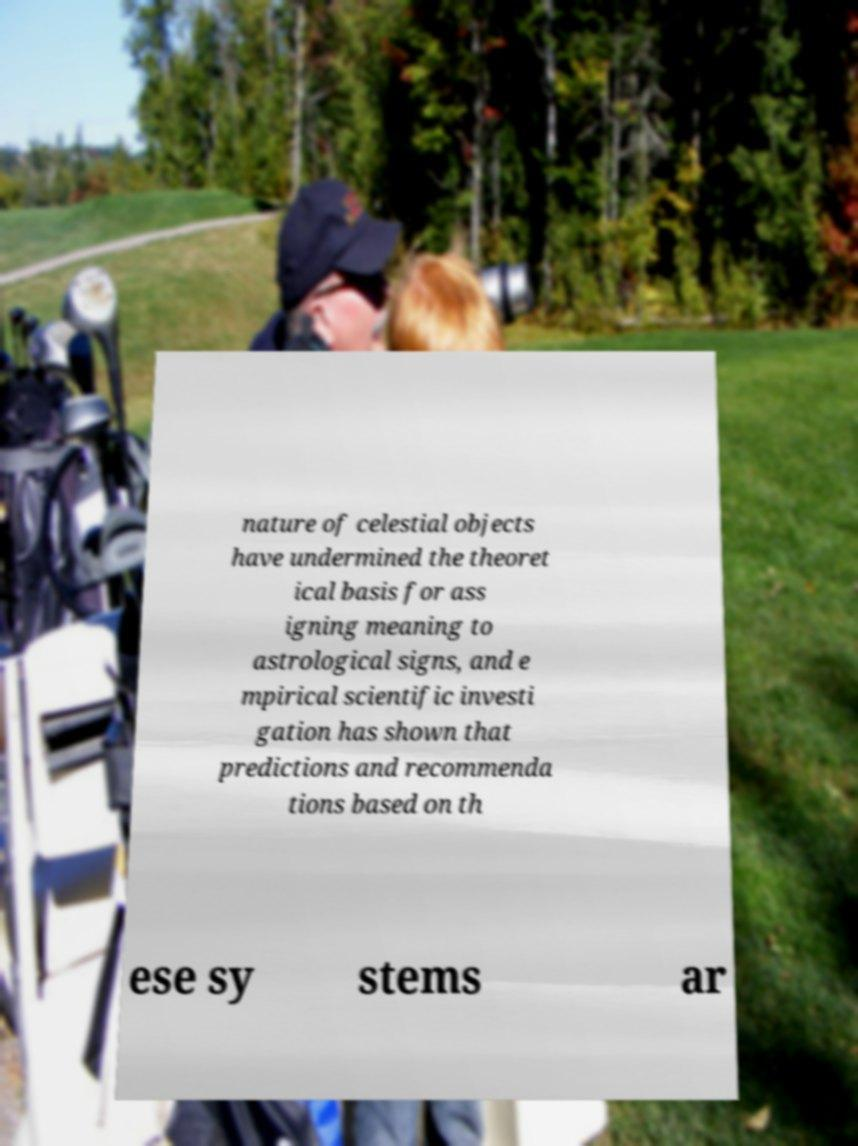For documentation purposes, I need the text within this image transcribed. Could you provide that? nature of celestial objects have undermined the theoret ical basis for ass igning meaning to astrological signs, and e mpirical scientific investi gation has shown that predictions and recommenda tions based on th ese sy stems ar 